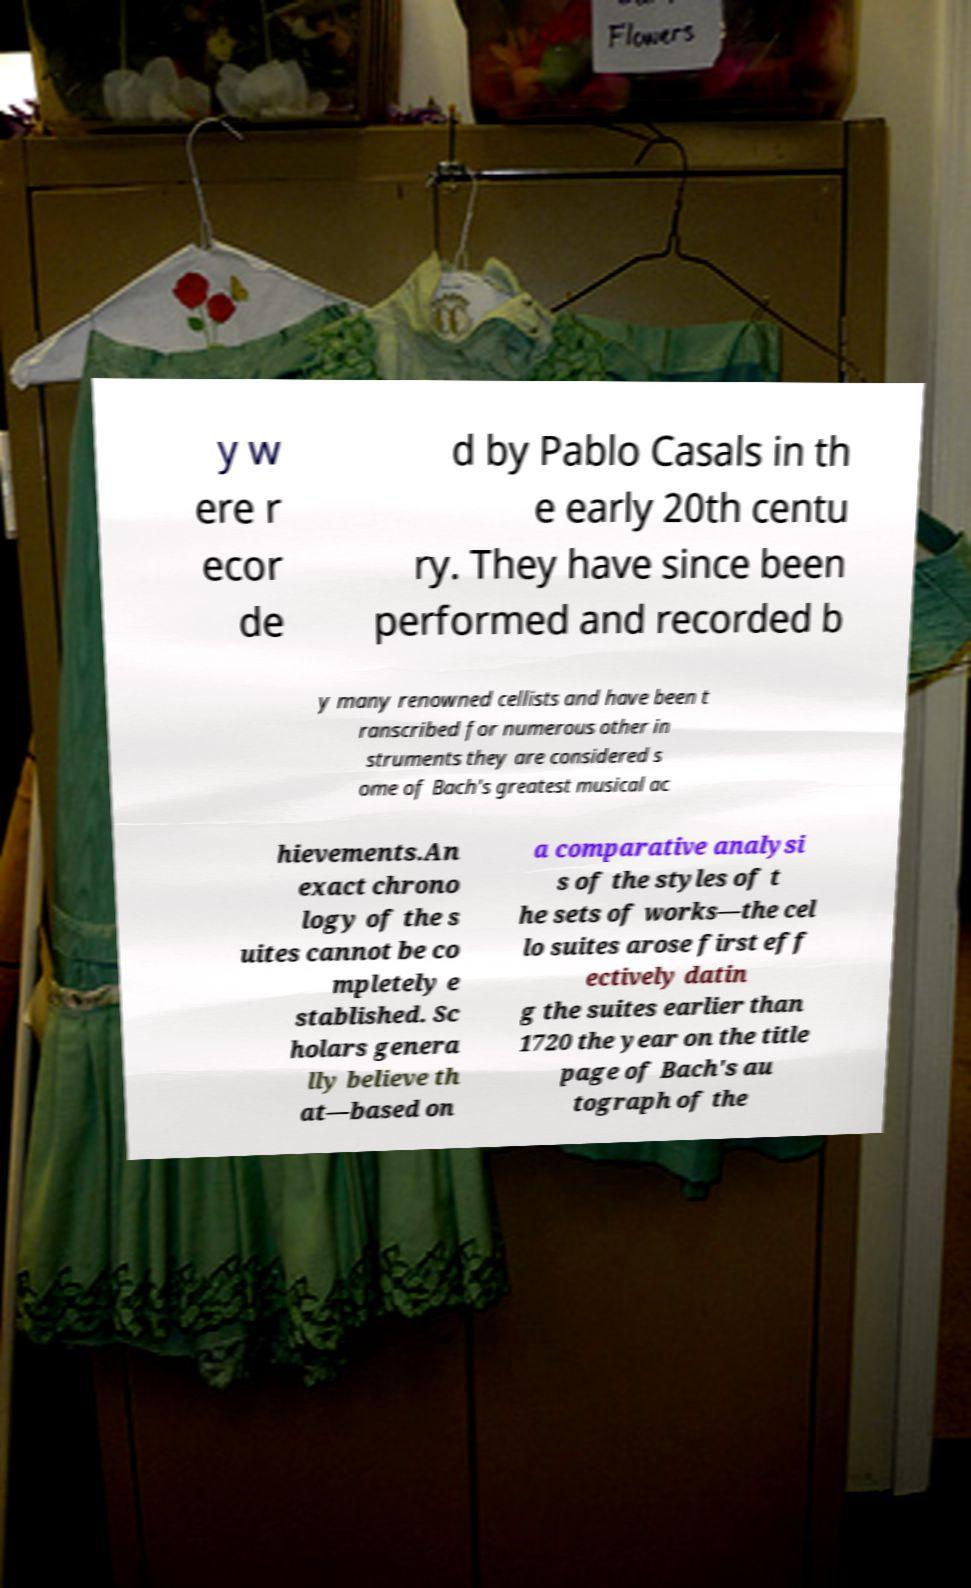Could you extract and type out the text from this image? y w ere r ecor de d by Pablo Casals in th e early 20th centu ry. They have since been performed and recorded b y many renowned cellists and have been t ranscribed for numerous other in struments they are considered s ome of Bach's greatest musical ac hievements.An exact chrono logy of the s uites cannot be co mpletely e stablished. Sc holars genera lly believe th at—based on a comparative analysi s of the styles of t he sets of works—the cel lo suites arose first eff ectively datin g the suites earlier than 1720 the year on the title page of Bach's au tograph of the 